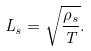Convert formula to latex. <formula><loc_0><loc_0><loc_500><loc_500>L _ { s } = \sqrt { \frac { \rho _ { s } } { T } } .</formula> 